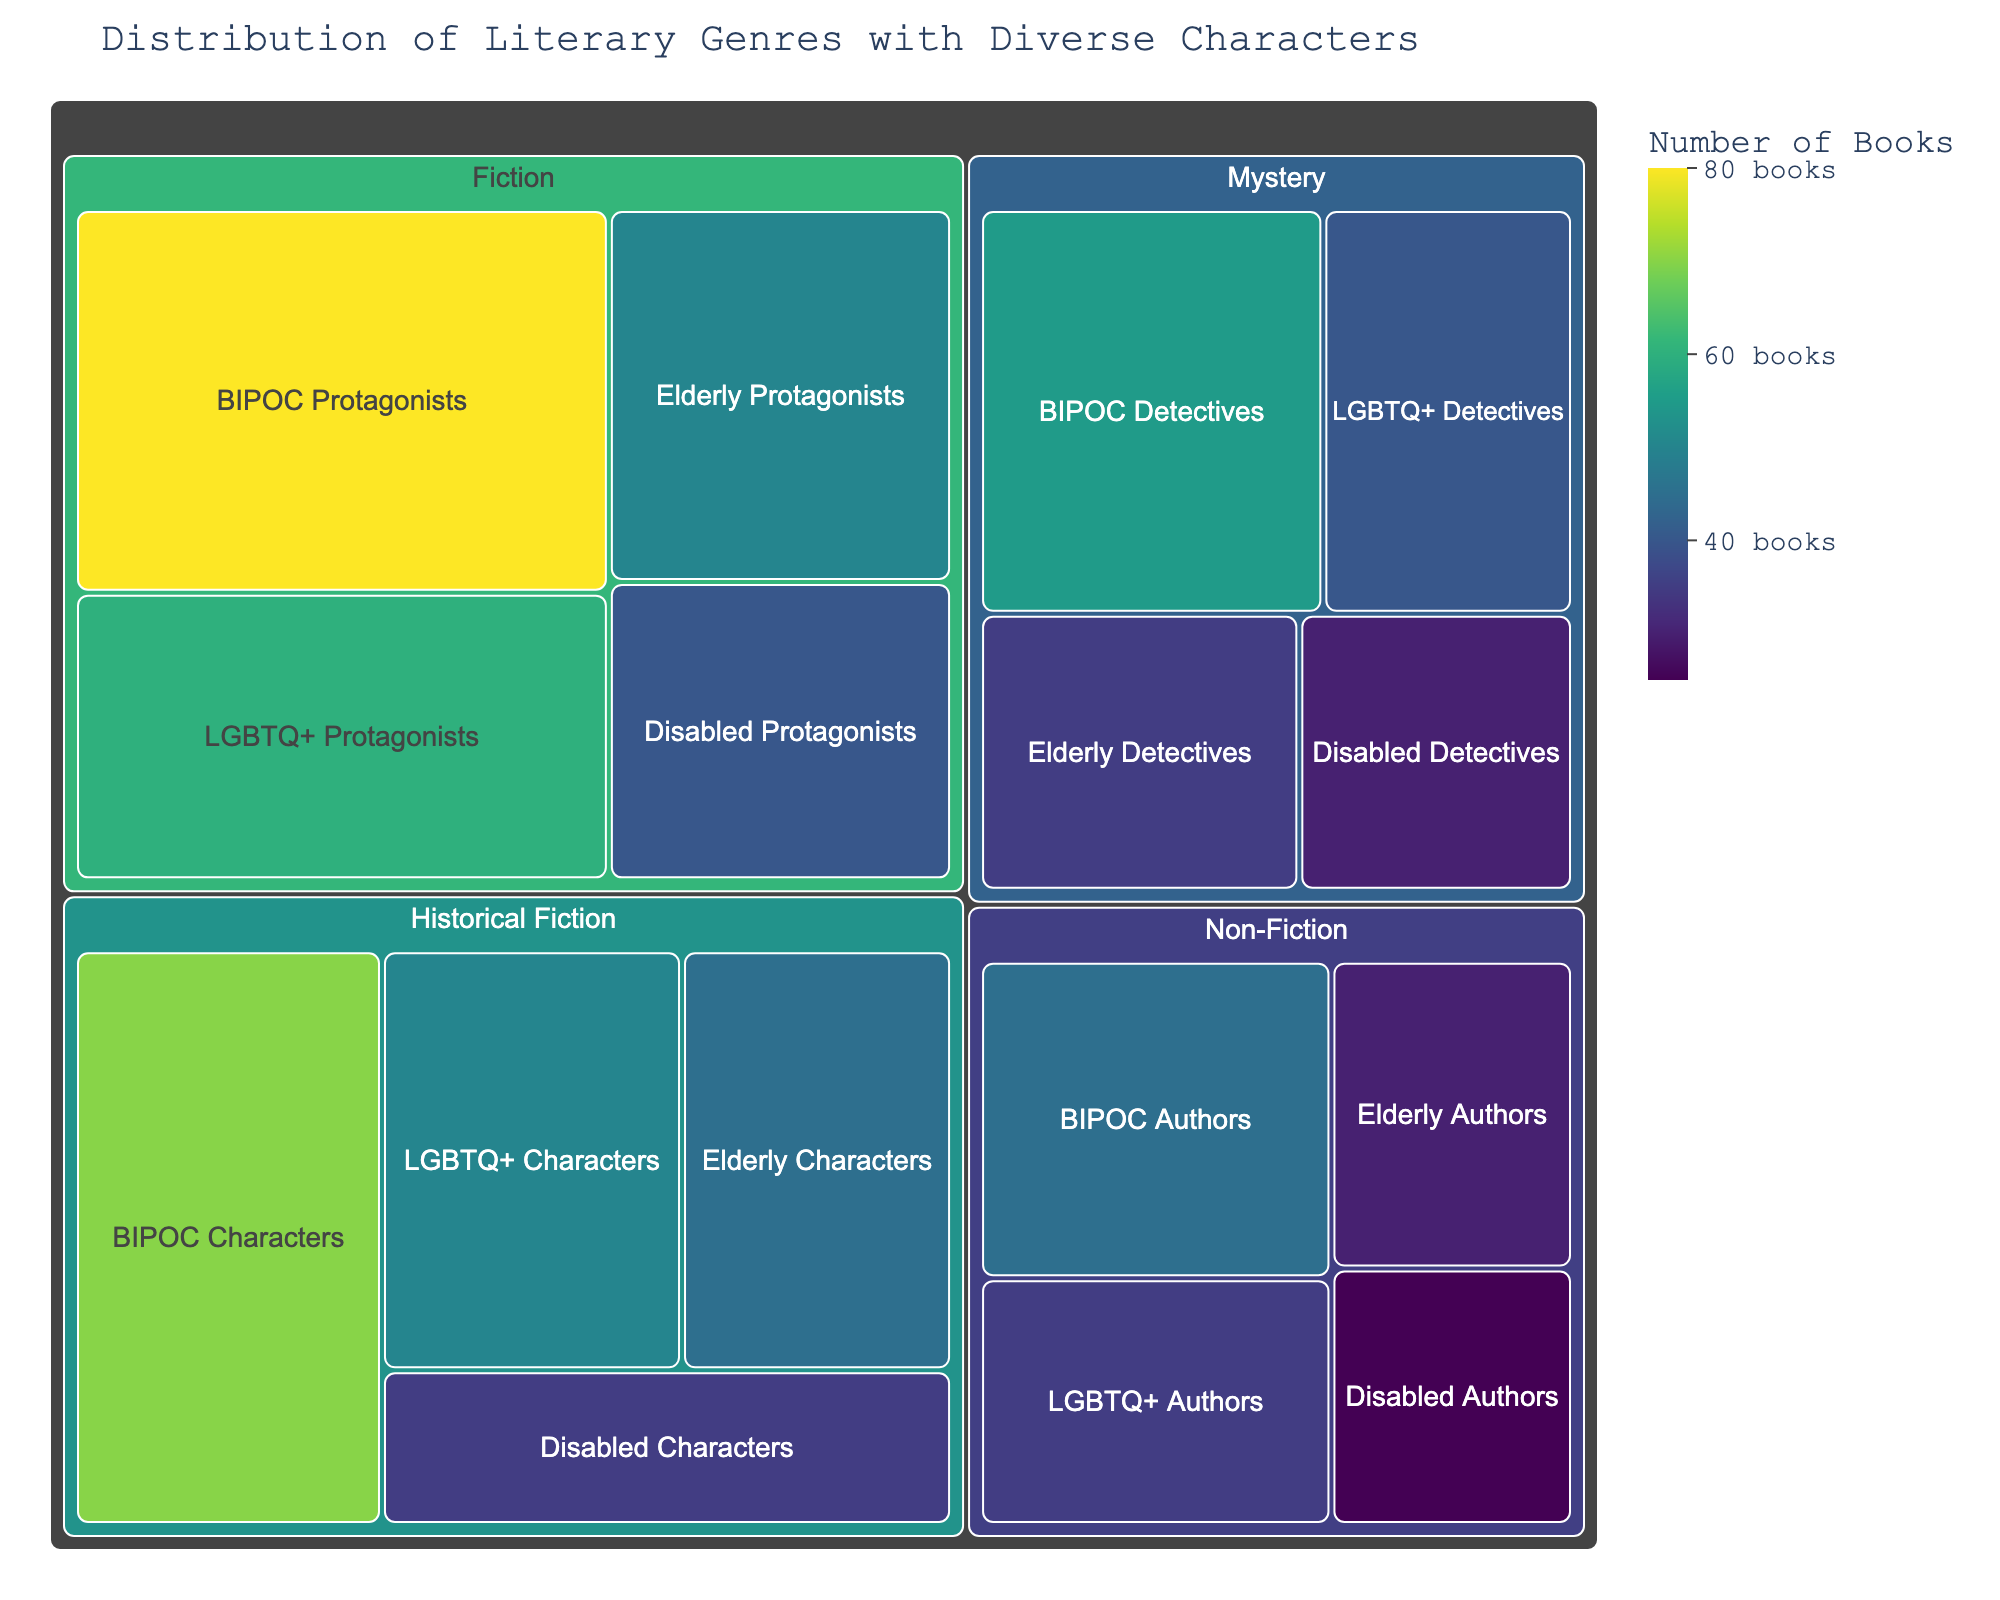What's the title of the figure? The title of the figure is displayed at the top and typically summarizes what the visualization represents. You can find it by looking at the text prominently displayed in that position.
Answer: Distribution of Literary Genres with Diverse Characters How many books feature BIPOC authors versus elderly authors? To answer this, locate the Non-Fiction section of the treemap and compare the values listed for BIPOC Authors and Elderly Authors. According to the data, BIPOC Authors have 45 books, and Elderly Authors have 30 books.
Answer: BIPOC Authors: 45, Elderly Authors: 30 Which genre has the most books featuring LGBTQ+ protagonists? Look at the number of books for LGBTQ+ Protagonists within each genre. According to the data, Fiction (60 books) has more than Mystery (40 books) and Historical Fiction (50 books).
Answer: Fiction What is the total number of books featuring disabled protagonists? You need to sum the number of books featuring disabled protagonists across all genres. According to the data: Fiction (40) + Non-Fiction (25) + Mystery (30) + Historical Fiction (35). This equals 130 books in total.
Answer: 130 Which demographic has the least representation in the Historical Fiction genre? To find this, compare the number of books for each demographic in the Historical Fiction genre. According to the data, Disabled Characters have the least representation with 35 books, compared to 45 (Elderly), 70 (BIPOC), and 50 (LGBTQ+).
Answer: Disabled Characters How does the number of books featuring BIPOC detectives compare to LGBTQ+ detectives in Mystery? Look at the Mystery section and compare the number of books that feature BIPOC Detectives and LGBTQ+ Detectives. According to the data, BIPOC Detectives have 55 books, and LGBTQ+ Detectives have 40 books.
Answer: BIPOC Detectives have 15 more books Which genre has the smallest number of books in total? To find this, add up the total books for each genre and compare. Based on the numbers provided:
- Fiction: 50 + 80 + 60 + 40 = 230
- Non-Fiction: 30 + 45 + 35 + 25 = 135
- Mystery: 35 + 55 + 40 + 30 = 160
- Historical Fiction: 45 + 70 + 50 + 35 = 200
Non-Fiction has the smallest total with 135 books.
Answer: Non-Fiction What is the proportion of books featuring elderly characters to total books in Fiction? First, find the total number of books in Fiction (230 books). Then, find the number for Elderly Protagonists (50 books). The proportion is 50/230. Simplify this fraction for the answer.
To simplify: 50 ÷ 230 = 0.217 (approximately 21.7%).
Answer: Approximately 21.7% 